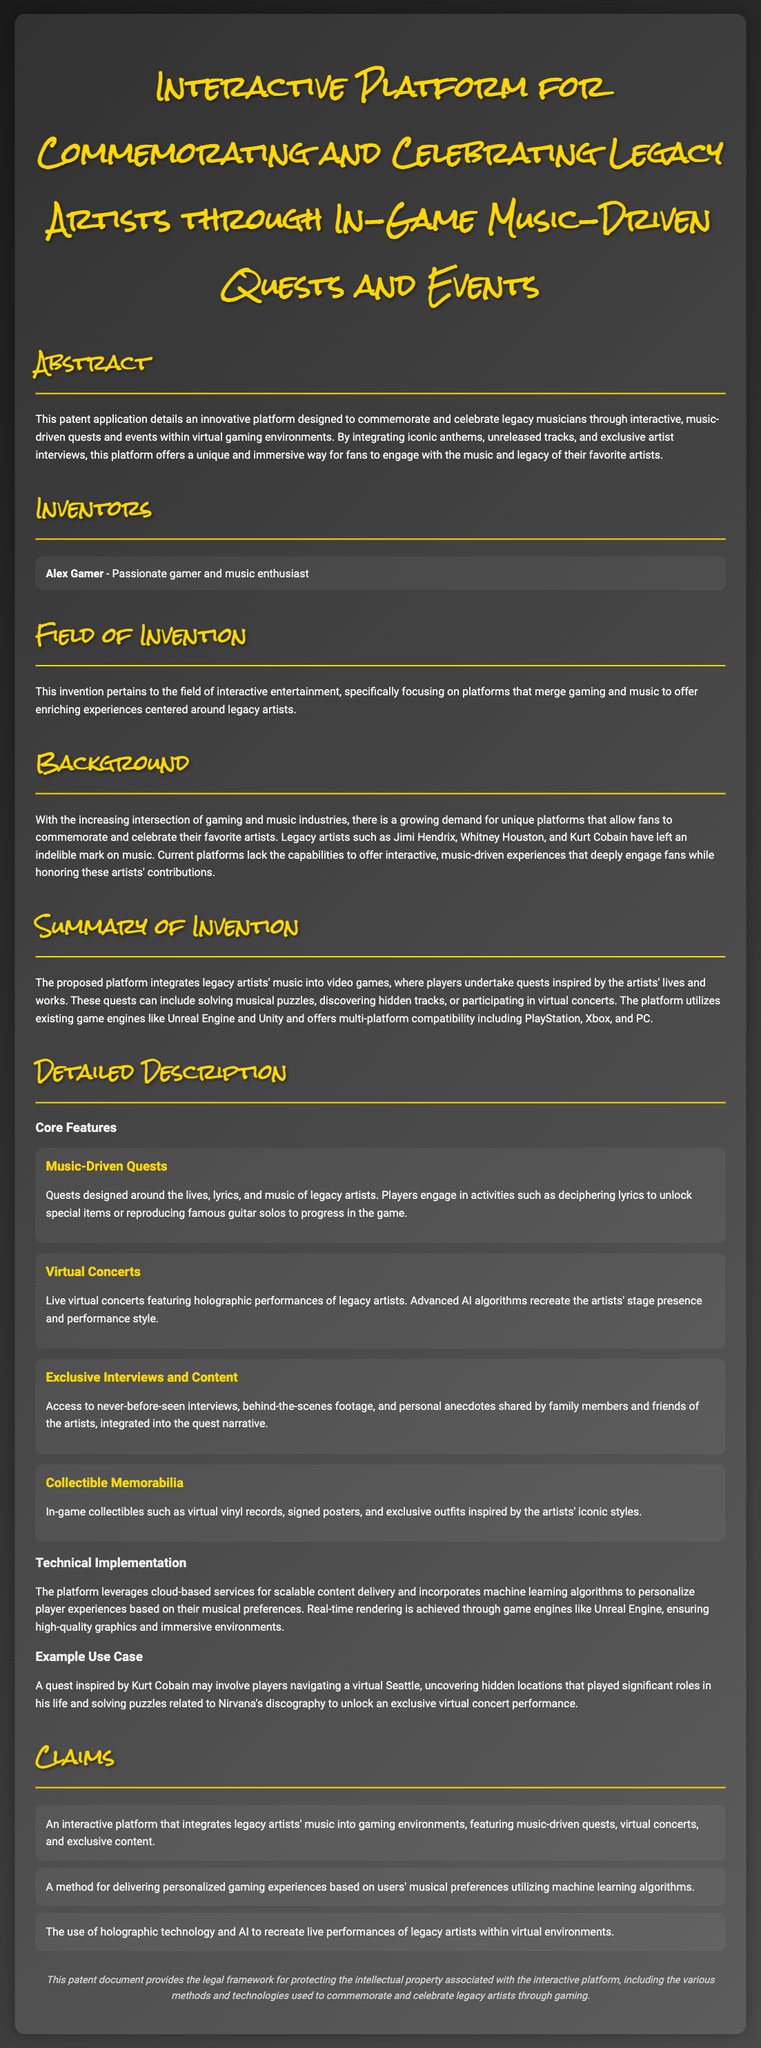What is the title of the patent application? The title of the patent application is prominently displayed at the top of the document.
Answer: Interactive Platform for Commemorating and Celebrating Legacy Artists through In-Game Music-Driven Quests and Events Who is the inventor of the platform? The document lists the inventor in the "Inventors" section.
Answer: Alex Gamer Which artists are mentioned as legacy artists in the background section? The background section references specific artists to illustrate the platform's purpose.
Answer: Jimi Hendrix, Whitney Houston, Kurt Cobain What technology is used for delivering personalized gaming experiences? The summary discusses the technological aspect used for enhancing user experience.
Answer: Machine learning algorithms What type of events does the platform include? The abstract mentions interactive elements incorporated into the platform.
Answer: Virtual concerts What item type can players collect in-game? The document lists features that include items that players can acquire.
Answer: Collectible memorabilia What kind of quests are featured within the platform? The core features outline the types of quests available to players.
Answer: Music-driven quests In what environments will the platform operate? The summary specifies the compatibility of the platform.
Answer: Multi-platform compatibility including PlayStation, Xbox, and PC What legal aspect does the patent document provide? The legal section summarizes the protective measures included in the document.
Answer: Legal framework for protecting intellectual property 